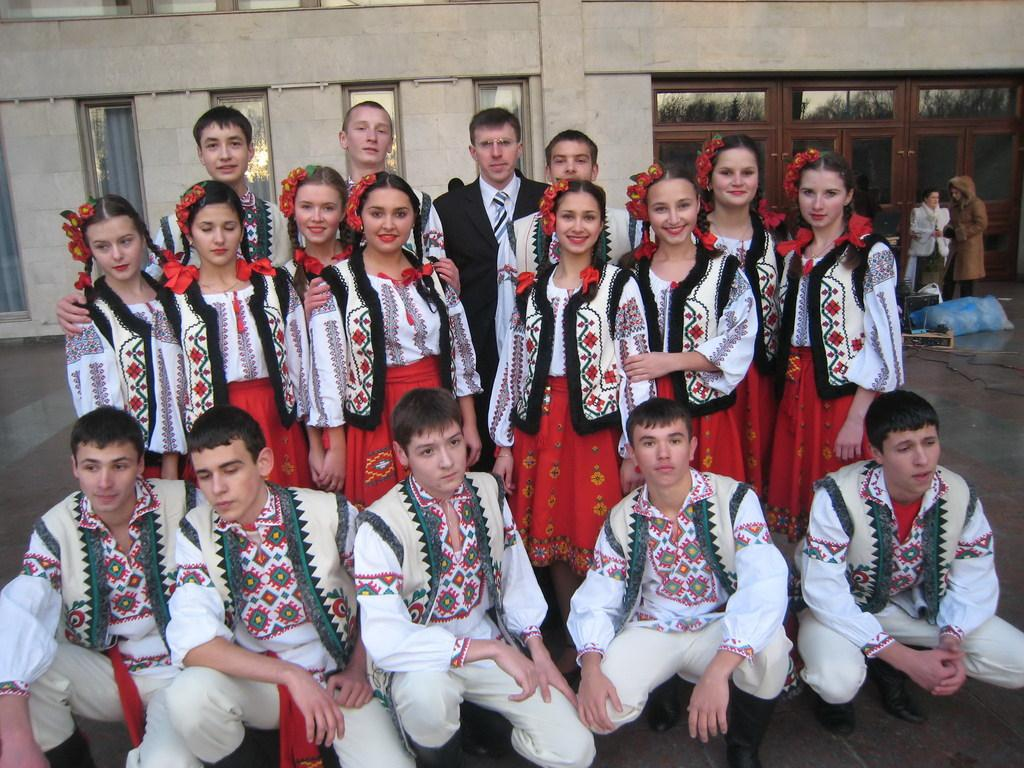How many people are present in the image? There are many people in the image. What are some of the people doing in the image? Some people are standing and laughing, while others are sitting in the squat position. What can be seen in the background of the image? There is a building in the background of the image. What type of education can be seen being taught in the image? There is no indication of education being taught in the image. How many dogs are present in the image? There are no dogs present in the image. 